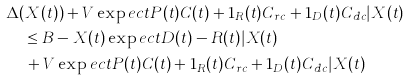Convert formula to latex. <formula><loc_0><loc_0><loc_500><loc_500>& \Delta ( X ( t ) ) + V \exp e c t { P ( t ) C ( t ) + 1 _ { R } ( t ) C _ { r c } + 1 _ { D } ( t ) C _ { d c } | X ( t ) } \\ & \quad \leq B - X ( t ) \exp e c t { D ( t ) - R ( t ) | X ( t ) } \\ & \quad \, + V \exp e c t { P ( t ) C ( t ) + 1 _ { R } ( t ) C _ { r c } + 1 _ { D } ( t ) C _ { d c } | X ( t ) }</formula> 